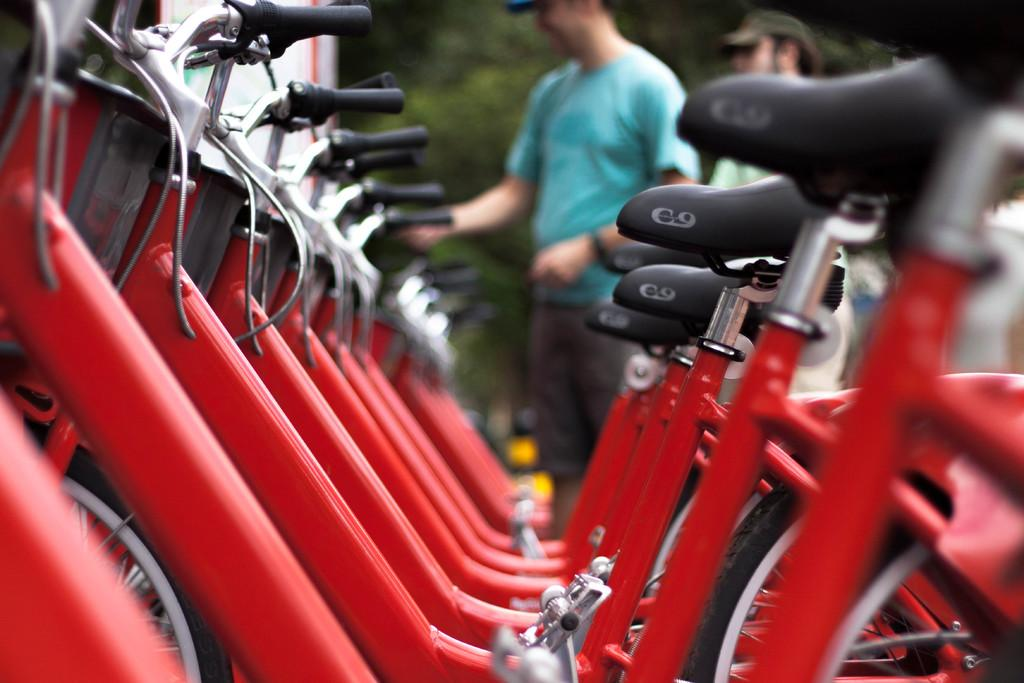Where was the image taken? The image is taken outdoors. What can be seen in the middle of the image? Many bicycles are parked in the middle of the image. How are the bicycles positioned in the image? The bicycles are parked on the floor. What can be seen in the background of the image? There are trees and two men standing in the background of the image. What type of clocks are hanging from the trees in the image? There are no clocks visible in the image; it only features bicycles, trees, and people in the background. 